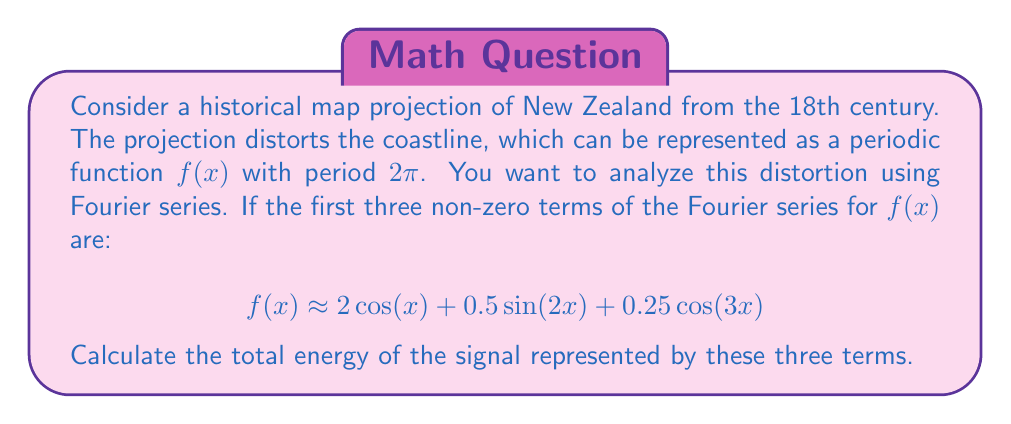Help me with this question. To solve this problem, we'll use Parseval's theorem, which relates the energy of a signal to its Fourier coefficients. For a periodic function $f(x)$ with period $2\pi$, Parseval's theorem states:

$$\frac{1}{2\pi}\int_0^{2\pi} |f(x)|^2 dx = \sum_{n=-\infty}^{\infty} |c_n|^2$$

Where $c_n$ are the Fourier coefficients.

In our case, we have:
1. $c_1 = c_{-1} = 1$ (for the $\cos(x)$ term)
2. $c_2 = -c_{-2} = 0.25i$ (for the $\sin(2x)$ term)
3. $c_3 = c_{-3} = 0.125$ (for the $\cos(3x)$ term)

The energy of the signal is given by the sum of the squares of these coefficients:

$$E = |c_{-3}|^2 + |c_{-2}|^2 + |c_{-1}|^2 + |c_0|^2 + |c_1|^2 + |c_2|^2 + |c_3|^2$$

Substituting the values:

$$E = 0.125^2 + 0.25^2 + 1^2 + 0^2 + 1^2 + 0.25^2 + 0.125^2$$

$$E = 0.015625 + 0.0625 + 1 + 0 + 1 + 0.0625 + 0.015625$$

$$E = 2.15625$$
Answer: The total energy of the signal represented by the first three non-zero terms of the Fourier series is $2.15625$. 